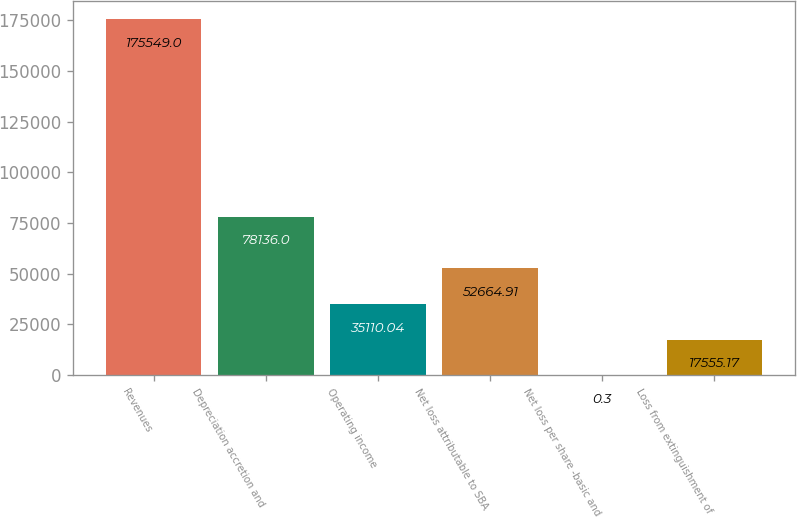Convert chart. <chart><loc_0><loc_0><loc_500><loc_500><bar_chart><fcel>Revenues<fcel>Depreciation accretion and<fcel>Operating income<fcel>Net loss attributable to SBA<fcel>Net loss per share -basic and<fcel>Loss from extinguishment of<nl><fcel>175549<fcel>78136<fcel>35110<fcel>52664.9<fcel>0.3<fcel>17555.2<nl></chart> 